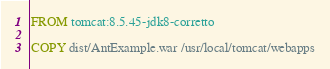<code> <loc_0><loc_0><loc_500><loc_500><_Dockerfile_>FROM tomcat:8.5.45-jdk8-corretto

COPY dist/AntExample.war /usr/local/tomcat/webapps
</code> 